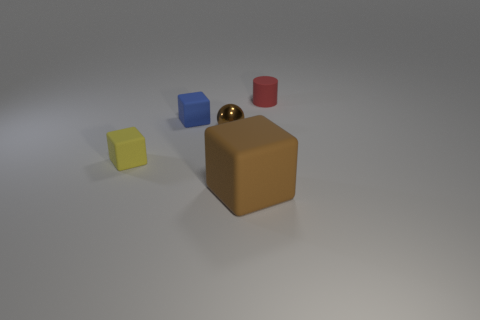Subtract all small blocks. How many blocks are left? 1 Subtract all brown blocks. How many blocks are left? 2 Add 1 balls. How many objects exist? 6 Subtract 2 cubes. How many cubes are left? 1 Subtract all cylinders. How many objects are left? 4 Subtract all blue balls. How many yellow blocks are left? 1 Add 4 big rubber things. How many big rubber things are left? 5 Add 4 tiny brown rubber spheres. How many tiny brown rubber spheres exist? 4 Subtract 0 red spheres. How many objects are left? 5 Subtract all cyan spheres. Subtract all green cubes. How many spheres are left? 1 